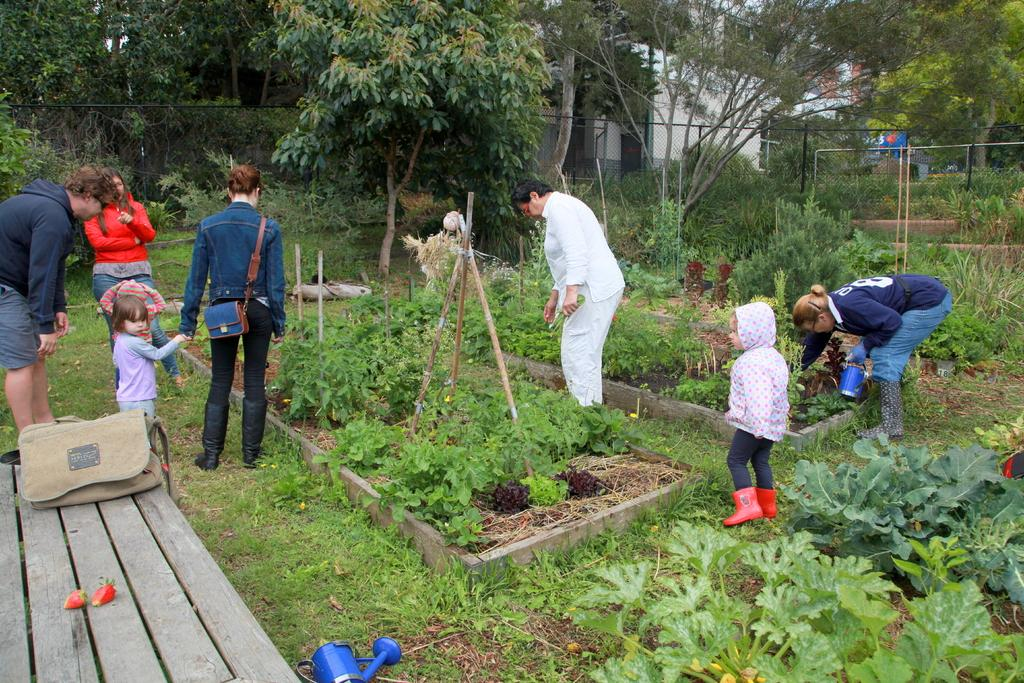How many people are in the image? There are people in the image, but the exact number is not specified. What is on the table in the image? There is a bag and strawberries on the table in the image. What type of plants are visible in the image? There are plants in the image, but the specific type is not mentioned. What are the wooden sticks used for in the image? The wooden sticks are present in the image, but their purpose is not specified. What color is the blue object in the image? There is a blue object in the image, but its exact shade or hue is not mentioned. What is the natural environment visible in the image? Grass is visible in the image, along with trees and a fence in the background. What type of structure can be seen in the background of the image? There is a building in the background of the image. What type of joke is being told by the wrist in the image? There is no wrist or joke present in the image. What act are the people in the image performing? The specific actions of the people in the image are not mentioned, so it is impossible to determine what act they might be performing. 